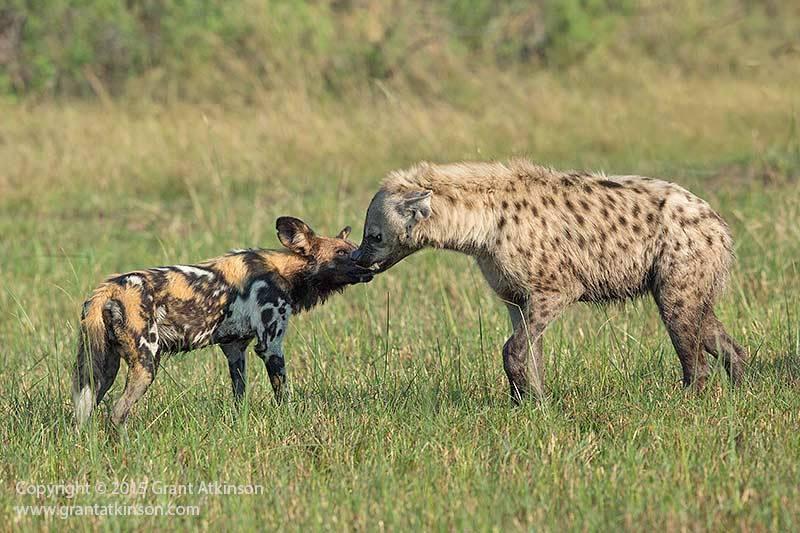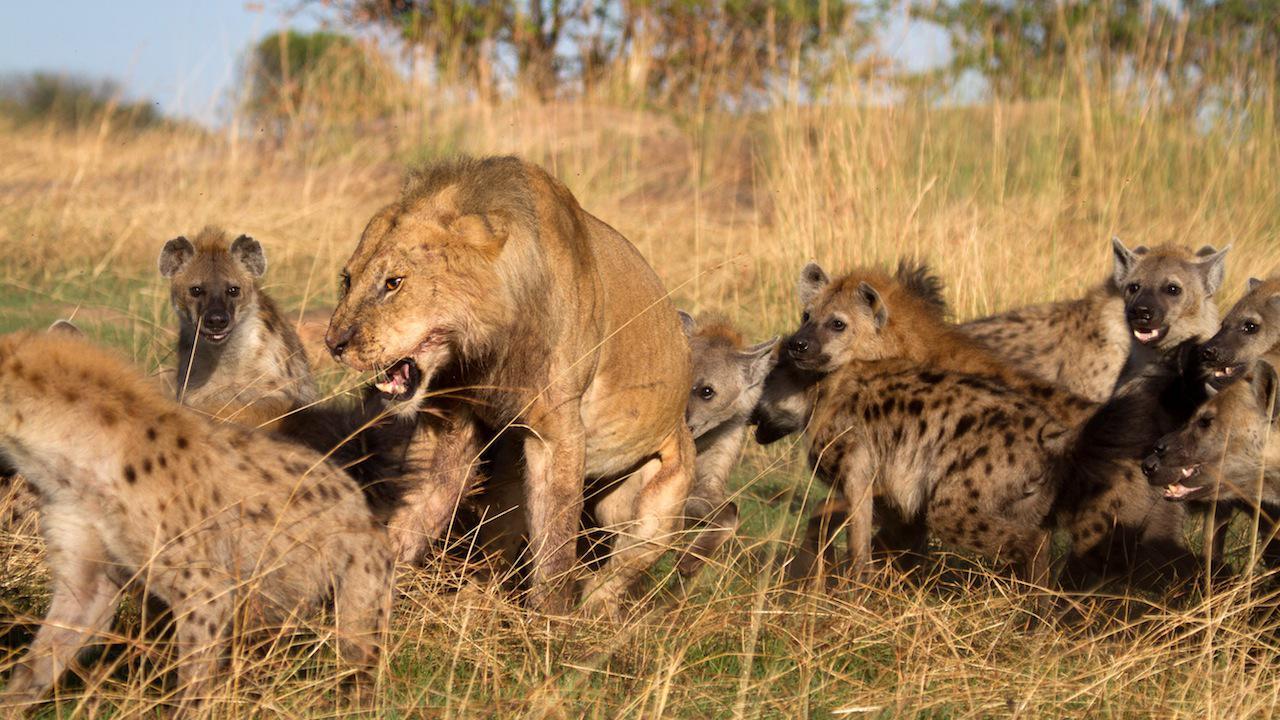The first image is the image on the left, the second image is the image on the right. Analyze the images presented: Is the assertion "In the image to the left, at least one african_wild_dog faces off against a hyena." valid? Answer yes or no. Yes. 